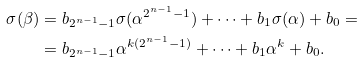Convert formula to latex. <formula><loc_0><loc_0><loc_500><loc_500>\sigma ( \beta ) & = b _ { 2 ^ { n - 1 } - 1 } \sigma ( \alpha ^ { 2 ^ { n - 1 } - 1 } ) + \dots + b _ { 1 } \sigma ( \alpha ) + b _ { 0 } = \\ & = b _ { 2 ^ { n - 1 } - 1 } \alpha ^ { k ( 2 ^ { n - 1 } - 1 ) } + \dots + b _ { 1 } \alpha ^ { k } + b _ { 0 } .</formula> 